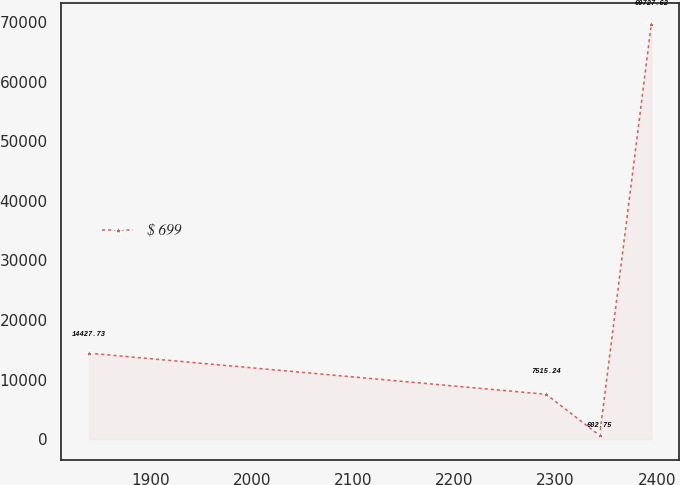Convert chart to OTSL. <chart><loc_0><loc_0><loc_500><loc_500><line_chart><ecel><fcel>$ 699<nl><fcel>1839.25<fcel>14427.7<nl><fcel>2290.82<fcel>7515.24<nl><fcel>2343.66<fcel>602.75<nl><fcel>2394.72<fcel>69727.6<nl></chart> 